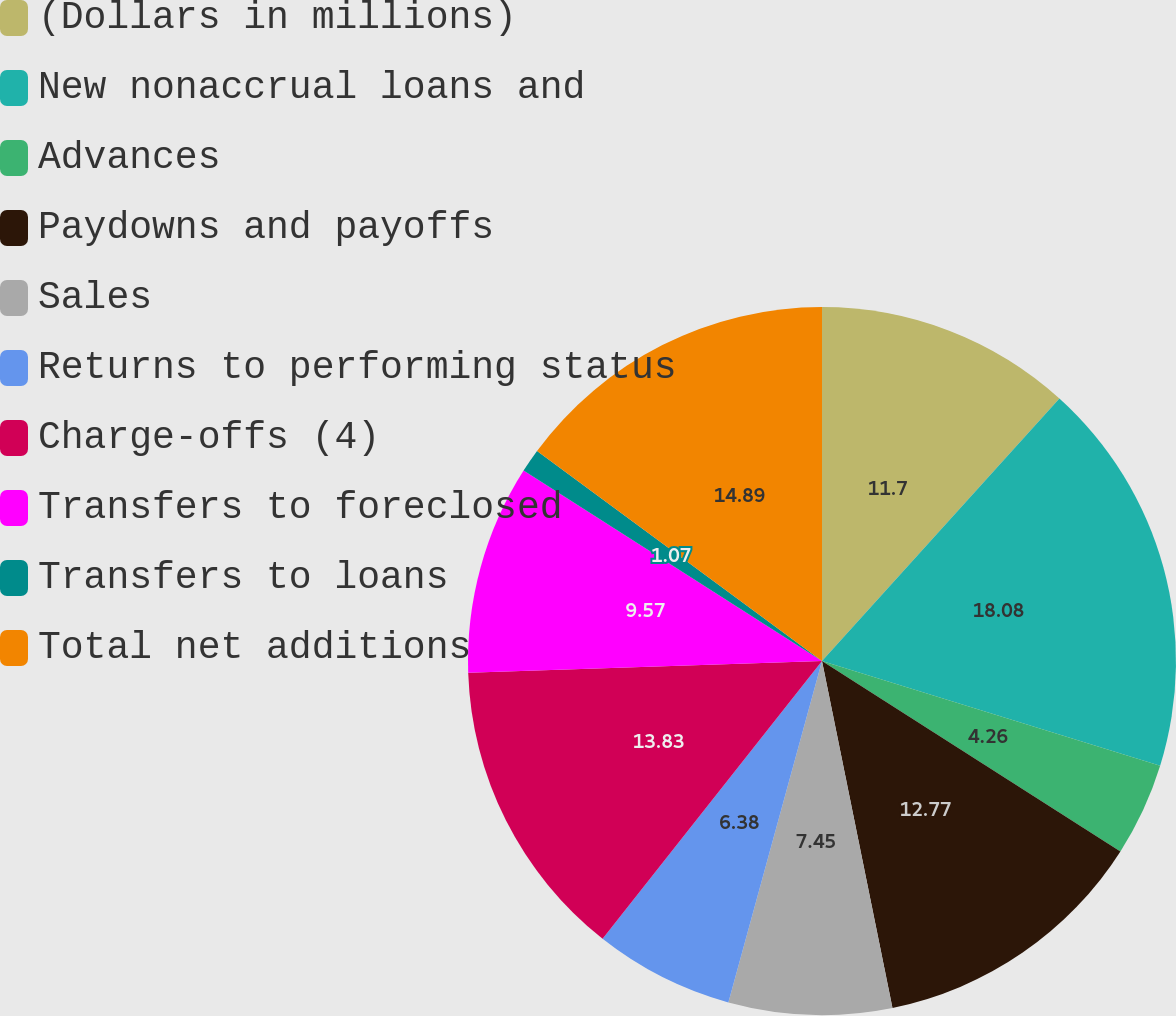<chart> <loc_0><loc_0><loc_500><loc_500><pie_chart><fcel>(Dollars in millions)<fcel>New nonaccrual loans and<fcel>Advances<fcel>Paydowns and payoffs<fcel>Sales<fcel>Returns to performing status<fcel>Charge-offs (4)<fcel>Transfers to foreclosed<fcel>Transfers to loans<fcel>Total net additions<nl><fcel>11.7%<fcel>18.08%<fcel>4.26%<fcel>12.77%<fcel>7.45%<fcel>6.38%<fcel>13.83%<fcel>9.57%<fcel>1.07%<fcel>14.89%<nl></chart> 